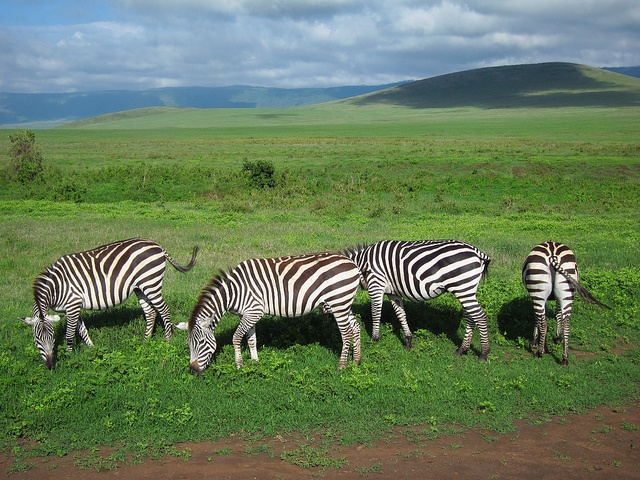Describe the objects in this image and their specific colors. I can see zebra in darkgray, ivory, gray, black, and maroon tones, zebra in darkgray, ivory, black, and gray tones, zebra in darkgray, black, white, and gray tones, and zebra in darkgray, black, ivory, and gray tones in this image. 